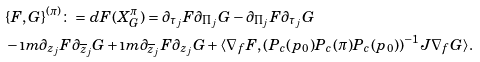Convert formula to latex. <formula><loc_0><loc_0><loc_500><loc_500>& \{ F , G \} ^ { ( \pi ) } \colon = d F ( X _ { G } ^ { \pi } ) = \partial _ { \tau _ { j } } F \partial _ { \Pi _ { j } } G - \partial _ { \Pi _ { j } } F \partial _ { \tau _ { j } } G \\ & - \i m \partial _ { z _ { j } } F \partial _ { \overline { z } _ { j } } G + \i m \partial _ { \overline { z } _ { j } } F \partial _ { z _ { j } } G + \langle \nabla _ { f } F , ( P _ { c } ( p _ { 0 } ) P _ { c } ( \pi ) P _ { c } ( p _ { 0 } ) ) ^ { - 1 } J \nabla _ { f } G \rangle .</formula> 